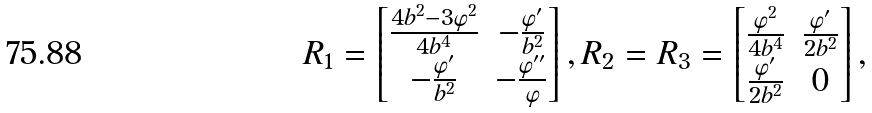Convert formula to latex. <formula><loc_0><loc_0><loc_500><loc_500>R _ { 1 } = \begin{bmatrix} \frac { 4 b ^ { 2 } - 3 \varphi ^ { 2 } } { 4 b ^ { 4 } } & - \frac { \varphi ^ { \prime } } { b ^ { 2 } } \\ - \frac { \varphi ^ { \prime } } { b ^ { 2 } } & - \frac { \varphi ^ { \prime \prime } } { \varphi } \end{bmatrix} , R _ { 2 } = R _ { 3 } = \begin{bmatrix} \frac { \varphi ^ { 2 } } { 4 b ^ { 4 } } & \frac { \varphi ^ { \prime } } { 2 b ^ { 2 } } \\ \frac { \varphi ^ { \prime } } { 2 b ^ { 2 } } & 0 \end{bmatrix} ,</formula> 